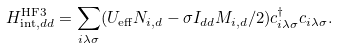<formula> <loc_0><loc_0><loc_500><loc_500>H _ { \text {int} , d d } ^ { \text {HF3} } = \sum _ { i \lambda \sigma } ( U _ { \text {eff} } N _ { i , d } - \sigma I _ { d d } M _ { i , d } / 2 ) c _ { i \lambda \sigma } ^ { \dag } c _ { i \lambda \sigma } .</formula> 